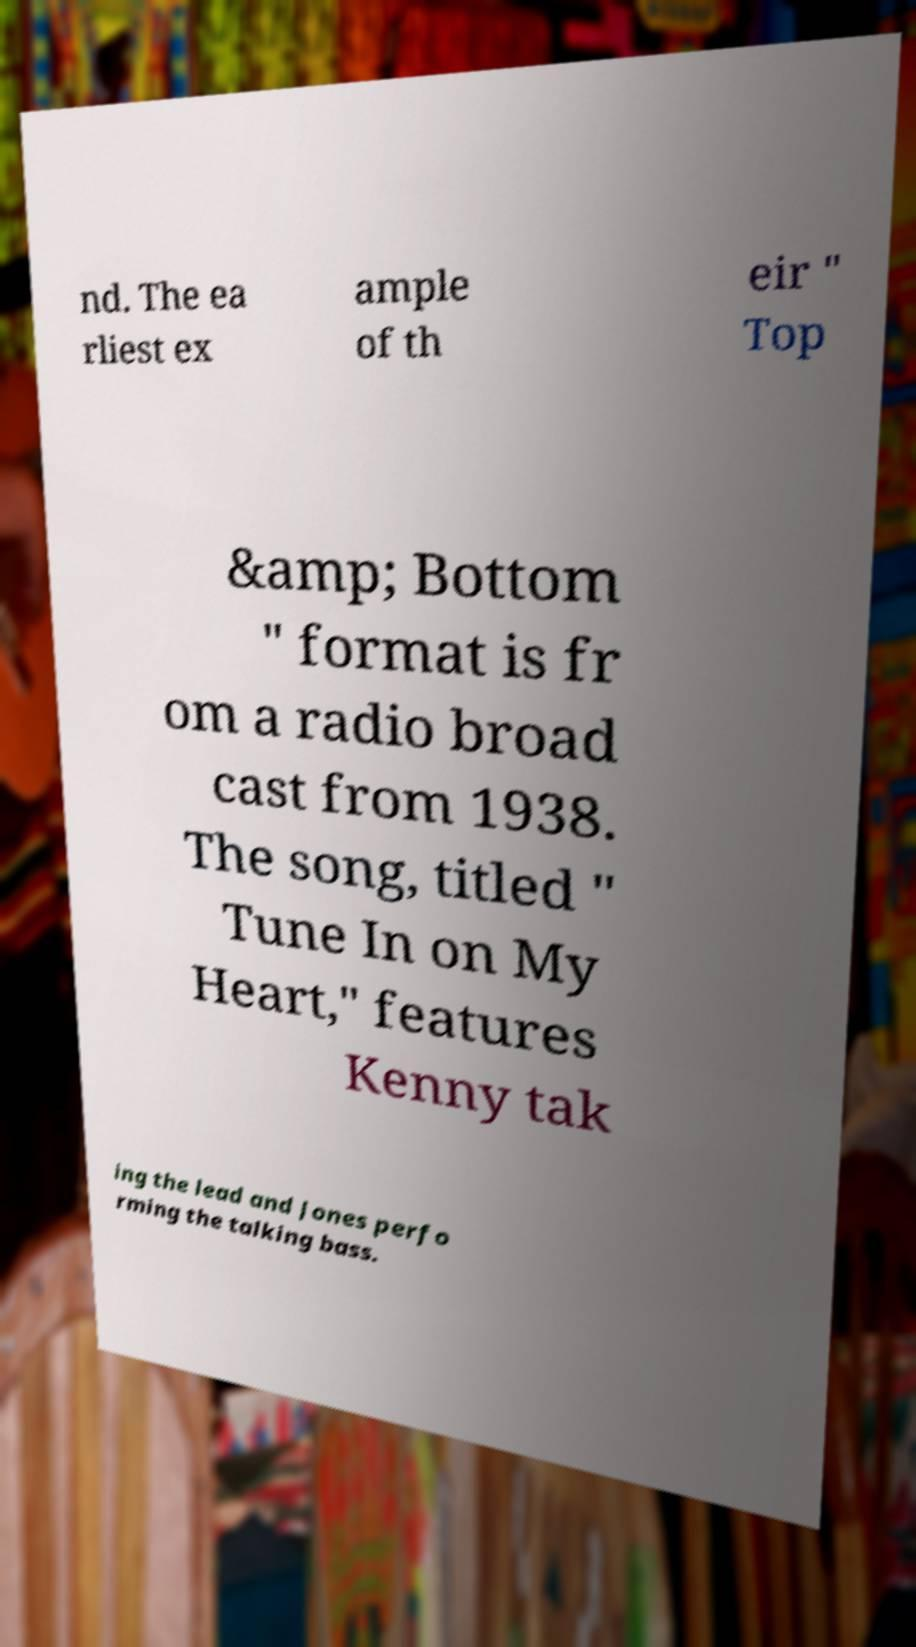Please read and relay the text visible in this image. What does it say? nd. The ea rliest ex ample of th eir " Top &amp; Bottom " format is fr om a radio broad cast from 1938. The song, titled " Tune In on My Heart," features Kenny tak ing the lead and Jones perfo rming the talking bass. 